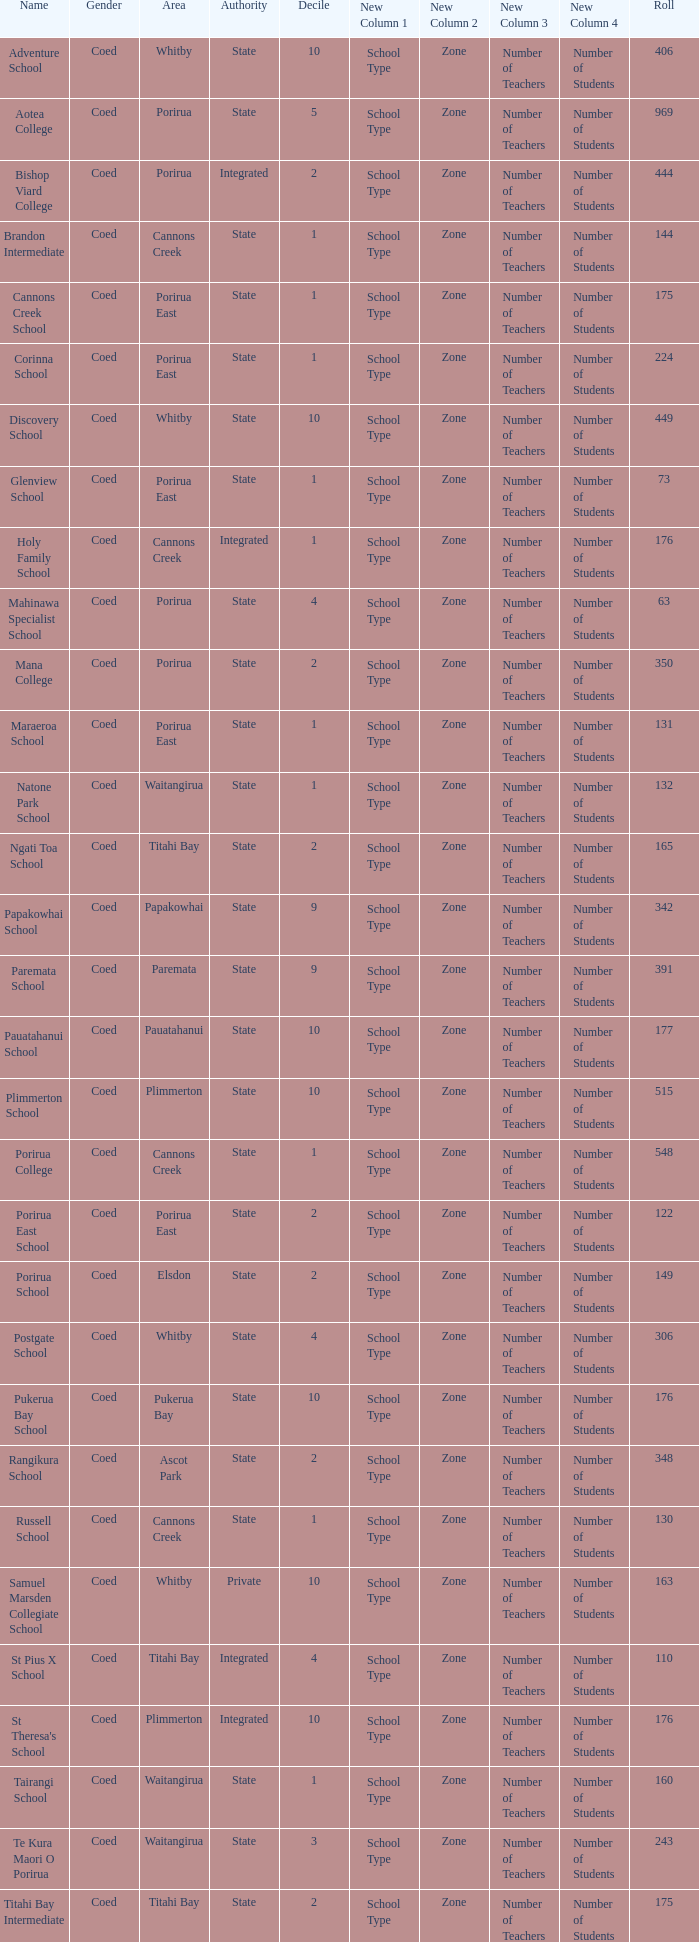What integrated school had a decile of 2 and a roll larger than 55? Bishop Viard College. 